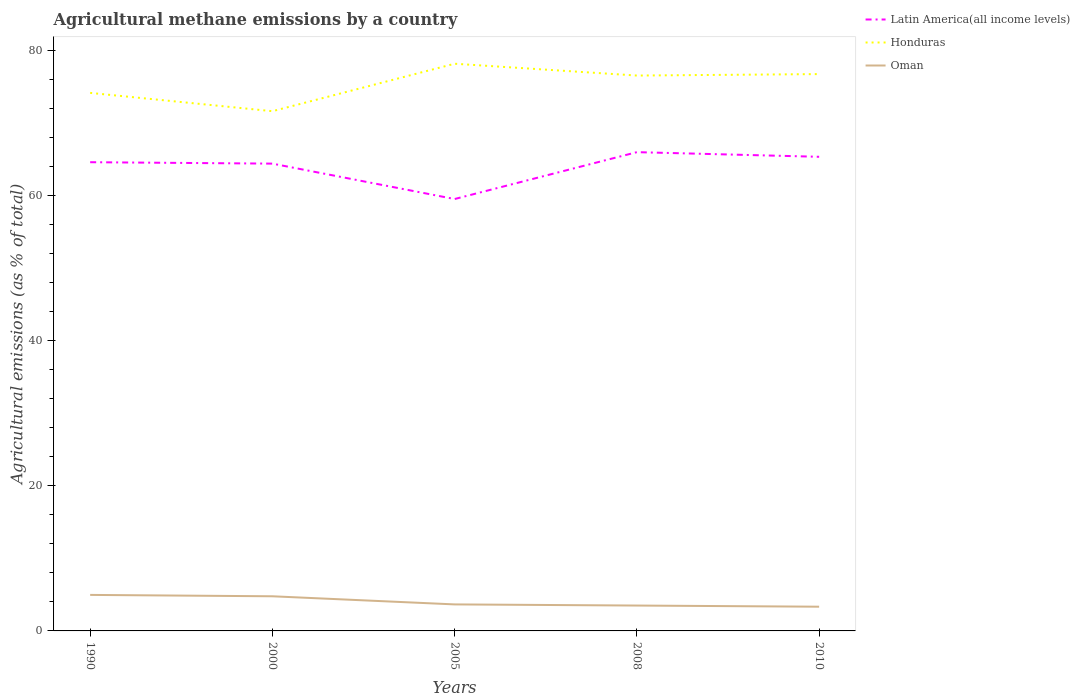How many different coloured lines are there?
Provide a succinct answer. 3. Across all years, what is the maximum amount of agricultural methane emitted in Latin America(all income levels)?
Offer a very short reply. 59.56. What is the total amount of agricultural methane emitted in Latin America(all income levels) in the graph?
Provide a succinct answer. -0.94. What is the difference between the highest and the second highest amount of agricultural methane emitted in Honduras?
Ensure brevity in your answer.  6.55. What is the difference between the highest and the lowest amount of agricultural methane emitted in Honduras?
Make the answer very short. 3. How many lines are there?
Keep it short and to the point. 3. Where does the legend appear in the graph?
Ensure brevity in your answer.  Top right. How are the legend labels stacked?
Offer a very short reply. Vertical. What is the title of the graph?
Ensure brevity in your answer.  Agricultural methane emissions by a country. Does "Monaco" appear as one of the legend labels in the graph?
Give a very brief answer. No. What is the label or title of the X-axis?
Keep it short and to the point. Years. What is the label or title of the Y-axis?
Your answer should be compact. Agricultural emissions (as % of total). What is the Agricultural emissions (as % of total) in Latin America(all income levels) in 1990?
Your response must be concise. 64.63. What is the Agricultural emissions (as % of total) of Honduras in 1990?
Ensure brevity in your answer.  74.19. What is the Agricultural emissions (as % of total) in Oman in 1990?
Give a very brief answer. 4.97. What is the Agricultural emissions (as % of total) in Latin America(all income levels) in 2000?
Make the answer very short. 64.44. What is the Agricultural emissions (as % of total) of Honduras in 2000?
Provide a succinct answer. 71.67. What is the Agricultural emissions (as % of total) of Oman in 2000?
Ensure brevity in your answer.  4.78. What is the Agricultural emissions (as % of total) of Latin America(all income levels) in 2005?
Your answer should be very brief. 59.56. What is the Agricultural emissions (as % of total) of Honduras in 2005?
Give a very brief answer. 78.21. What is the Agricultural emissions (as % of total) in Oman in 2005?
Your answer should be very brief. 3.66. What is the Agricultural emissions (as % of total) in Latin America(all income levels) in 2008?
Provide a short and direct response. 66.02. What is the Agricultural emissions (as % of total) of Honduras in 2008?
Provide a succinct answer. 76.58. What is the Agricultural emissions (as % of total) of Oman in 2008?
Give a very brief answer. 3.5. What is the Agricultural emissions (as % of total) in Latin America(all income levels) in 2010?
Your answer should be compact. 65.38. What is the Agricultural emissions (as % of total) of Honduras in 2010?
Your answer should be compact. 76.78. What is the Agricultural emissions (as % of total) in Oman in 2010?
Give a very brief answer. 3.34. Across all years, what is the maximum Agricultural emissions (as % of total) in Latin America(all income levels)?
Your answer should be very brief. 66.02. Across all years, what is the maximum Agricultural emissions (as % of total) of Honduras?
Provide a succinct answer. 78.21. Across all years, what is the maximum Agricultural emissions (as % of total) of Oman?
Your answer should be compact. 4.97. Across all years, what is the minimum Agricultural emissions (as % of total) in Latin America(all income levels)?
Your answer should be very brief. 59.56. Across all years, what is the minimum Agricultural emissions (as % of total) of Honduras?
Ensure brevity in your answer.  71.67. Across all years, what is the minimum Agricultural emissions (as % of total) of Oman?
Your answer should be compact. 3.34. What is the total Agricultural emissions (as % of total) in Latin America(all income levels) in the graph?
Offer a terse response. 320.03. What is the total Agricultural emissions (as % of total) in Honduras in the graph?
Make the answer very short. 377.44. What is the total Agricultural emissions (as % of total) of Oman in the graph?
Offer a very short reply. 20.24. What is the difference between the Agricultural emissions (as % of total) of Latin America(all income levels) in 1990 and that in 2000?
Your answer should be very brief. 0.2. What is the difference between the Agricultural emissions (as % of total) of Honduras in 1990 and that in 2000?
Offer a terse response. 2.52. What is the difference between the Agricultural emissions (as % of total) in Oman in 1990 and that in 2000?
Give a very brief answer. 0.19. What is the difference between the Agricultural emissions (as % of total) in Latin America(all income levels) in 1990 and that in 2005?
Keep it short and to the point. 5.08. What is the difference between the Agricultural emissions (as % of total) in Honduras in 1990 and that in 2005?
Keep it short and to the point. -4.02. What is the difference between the Agricultural emissions (as % of total) in Oman in 1990 and that in 2005?
Make the answer very short. 1.31. What is the difference between the Agricultural emissions (as % of total) in Latin America(all income levels) in 1990 and that in 2008?
Offer a very short reply. -1.39. What is the difference between the Agricultural emissions (as % of total) of Honduras in 1990 and that in 2008?
Offer a very short reply. -2.39. What is the difference between the Agricultural emissions (as % of total) in Oman in 1990 and that in 2008?
Provide a short and direct response. 1.47. What is the difference between the Agricultural emissions (as % of total) in Latin America(all income levels) in 1990 and that in 2010?
Keep it short and to the point. -0.75. What is the difference between the Agricultural emissions (as % of total) in Honduras in 1990 and that in 2010?
Provide a short and direct response. -2.59. What is the difference between the Agricultural emissions (as % of total) of Oman in 1990 and that in 2010?
Make the answer very short. 1.63. What is the difference between the Agricultural emissions (as % of total) of Latin America(all income levels) in 2000 and that in 2005?
Your response must be concise. 4.88. What is the difference between the Agricultural emissions (as % of total) of Honduras in 2000 and that in 2005?
Offer a very short reply. -6.55. What is the difference between the Agricultural emissions (as % of total) of Oman in 2000 and that in 2005?
Your answer should be compact. 1.12. What is the difference between the Agricultural emissions (as % of total) in Latin America(all income levels) in 2000 and that in 2008?
Offer a very short reply. -1.58. What is the difference between the Agricultural emissions (as % of total) in Honduras in 2000 and that in 2008?
Provide a succinct answer. -4.92. What is the difference between the Agricultural emissions (as % of total) of Oman in 2000 and that in 2008?
Give a very brief answer. 1.28. What is the difference between the Agricultural emissions (as % of total) in Latin America(all income levels) in 2000 and that in 2010?
Your answer should be very brief. -0.94. What is the difference between the Agricultural emissions (as % of total) of Honduras in 2000 and that in 2010?
Offer a terse response. -5.12. What is the difference between the Agricultural emissions (as % of total) of Oman in 2000 and that in 2010?
Your answer should be compact. 1.44. What is the difference between the Agricultural emissions (as % of total) in Latin America(all income levels) in 2005 and that in 2008?
Keep it short and to the point. -6.46. What is the difference between the Agricultural emissions (as % of total) of Honduras in 2005 and that in 2008?
Provide a succinct answer. 1.63. What is the difference between the Agricultural emissions (as % of total) in Oman in 2005 and that in 2008?
Provide a short and direct response. 0.16. What is the difference between the Agricultural emissions (as % of total) of Latin America(all income levels) in 2005 and that in 2010?
Your response must be concise. -5.82. What is the difference between the Agricultural emissions (as % of total) in Honduras in 2005 and that in 2010?
Provide a succinct answer. 1.43. What is the difference between the Agricultural emissions (as % of total) of Oman in 2005 and that in 2010?
Ensure brevity in your answer.  0.32. What is the difference between the Agricultural emissions (as % of total) of Latin America(all income levels) in 2008 and that in 2010?
Provide a short and direct response. 0.64. What is the difference between the Agricultural emissions (as % of total) in Honduras in 2008 and that in 2010?
Your answer should be compact. -0.2. What is the difference between the Agricultural emissions (as % of total) of Oman in 2008 and that in 2010?
Your answer should be compact. 0.16. What is the difference between the Agricultural emissions (as % of total) of Latin America(all income levels) in 1990 and the Agricultural emissions (as % of total) of Honduras in 2000?
Offer a very short reply. -7.03. What is the difference between the Agricultural emissions (as % of total) in Latin America(all income levels) in 1990 and the Agricultural emissions (as % of total) in Oman in 2000?
Offer a very short reply. 59.86. What is the difference between the Agricultural emissions (as % of total) of Honduras in 1990 and the Agricultural emissions (as % of total) of Oman in 2000?
Provide a succinct answer. 69.42. What is the difference between the Agricultural emissions (as % of total) of Latin America(all income levels) in 1990 and the Agricultural emissions (as % of total) of Honduras in 2005?
Provide a short and direct response. -13.58. What is the difference between the Agricultural emissions (as % of total) in Latin America(all income levels) in 1990 and the Agricultural emissions (as % of total) in Oman in 2005?
Your response must be concise. 60.98. What is the difference between the Agricultural emissions (as % of total) in Honduras in 1990 and the Agricultural emissions (as % of total) in Oman in 2005?
Keep it short and to the point. 70.54. What is the difference between the Agricultural emissions (as % of total) in Latin America(all income levels) in 1990 and the Agricultural emissions (as % of total) in Honduras in 2008?
Keep it short and to the point. -11.95. What is the difference between the Agricultural emissions (as % of total) in Latin America(all income levels) in 1990 and the Agricultural emissions (as % of total) in Oman in 2008?
Keep it short and to the point. 61.14. What is the difference between the Agricultural emissions (as % of total) in Honduras in 1990 and the Agricultural emissions (as % of total) in Oman in 2008?
Provide a succinct answer. 70.69. What is the difference between the Agricultural emissions (as % of total) in Latin America(all income levels) in 1990 and the Agricultural emissions (as % of total) in Honduras in 2010?
Ensure brevity in your answer.  -12.15. What is the difference between the Agricultural emissions (as % of total) of Latin America(all income levels) in 1990 and the Agricultural emissions (as % of total) of Oman in 2010?
Make the answer very short. 61.3. What is the difference between the Agricultural emissions (as % of total) of Honduras in 1990 and the Agricultural emissions (as % of total) of Oman in 2010?
Offer a very short reply. 70.85. What is the difference between the Agricultural emissions (as % of total) in Latin America(all income levels) in 2000 and the Agricultural emissions (as % of total) in Honduras in 2005?
Make the answer very short. -13.78. What is the difference between the Agricultural emissions (as % of total) of Latin America(all income levels) in 2000 and the Agricultural emissions (as % of total) of Oman in 2005?
Provide a succinct answer. 60.78. What is the difference between the Agricultural emissions (as % of total) in Honduras in 2000 and the Agricultural emissions (as % of total) in Oman in 2005?
Keep it short and to the point. 68.01. What is the difference between the Agricultural emissions (as % of total) of Latin America(all income levels) in 2000 and the Agricultural emissions (as % of total) of Honduras in 2008?
Offer a very short reply. -12.15. What is the difference between the Agricultural emissions (as % of total) of Latin America(all income levels) in 2000 and the Agricultural emissions (as % of total) of Oman in 2008?
Your answer should be compact. 60.94. What is the difference between the Agricultural emissions (as % of total) of Honduras in 2000 and the Agricultural emissions (as % of total) of Oman in 2008?
Provide a short and direct response. 68.17. What is the difference between the Agricultural emissions (as % of total) of Latin America(all income levels) in 2000 and the Agricultural emissions (as % of total) of Honduras in 2010?
Your answer should be compact. -12.35. What is the difference between the Agricultural emissions (as % of total) of Latin America(all income levels) in 2000 and the Agricultural emissions (as % of total) of Oman in 2010?
Ensure brevity in your answer.  61.1. What is the difference between the Agricultural emissions (as % of total) of Honduras in 2000 and the Agricultural emissions (as % of total) of Oman in 2010?
Your answer should be very brief. 68.33. What is the difference between the Agricultural emissions (as % of total) in Latin America(all income levels) in 2005 and the Agricultural emissions (as % of total) in Honduras in 2008?
Your answer should be very brief. -17.03. What is the difference between the Agricultural emissions (as % of total) in Latin America(all income levels) in 2005 and the Agricultural emissions (as % of total) in Oman in 2008?
Make the answer very short. 56.06. What is the difference between the Agricultural emissions (as % of total) of Honduras in 2005 and the Agricultural emissions (as % of total) of Oman in 2008?
Provide a short and direct response. 74.71. What is the difference between the Agricultural emissions (as % of total) of Latin America(all income levels) in 2005 and the Agricultural emissions (as % of total) of Honduras in 2010?
Make the answer very short. -17.23. What is the difference between the Agricultural emissions (as % of total) in Latin America(all income levels) in 2005 and the Agricultural emissions (as % of total) in Oman in 2010?
Provide a short and direct response. 56.22. What is the difference between the Agricultural emissions (as % of total) of Honduras in 2005 and the Agricultural emissions (as % of total) of Oman in 2010?
Your answer should be very brief. 74.88. What is the difference between the Agricultural emissions (as % of total) of Latin America(all income levels) in 2008 and the Agricultural emissions (as % of total) of Honduras in 2010?
Ensure brevity in your answer.  -10.76. What is the difference between the Agricultural emissions (as % of total) in Latin America(all income levels) in 2008 and the Agricultural emissions (as % of total) in Oman in 2010?
Your answer should be compact. 62.68. What is the difference between the Agricultural emissions (as % of total) in Honduras in 2008 and the Agricultural emissions (as % of total) in Oman in 2010?
Make the answer very short. 73.24. What is the average Agricultural emissions (as % of total) in Latin America(all income levels) per year?
Provide a succinct answer. 64.01. What is the average Agricultural emissions (as % of total) in Honduras per year?
Provide a short and direct response. 75.49. What is the average Agricultural emissions (as % of total) of Oman per year?
Your response must be concise. 4.05. In the year 1990, what is the difference between the Agricultural emissions (as % of total) of Latin America(all income levels) and Agricultural emissions (as % of total) of Honduras?
Make the answer very short. -9.56. In the year 1990, what is the difference between the Agricultural emissions (as % of total) in Latin America(all income levels) and Agricultural emissions (as % of total) in Oman?
Your answer should be compact. 59.67. In the year 1990, what is the difference between the Agricultural emissions (as % of total) in Honduras and Agricultural emissions (as % of total) in Oman?
Offer a terse response. 69.23. In the year 2000, what is the difference between the Agricultural emissions (as % of total) of Latin America(all income levels) and Agricultural emissions (as % of total) of Honduras?
Provide a short and direct response. -7.23. In the year 2000, what is the difference between the Agricultural emissions (as % of total) in Latin America(all income levels) and Agricultural emissions (as % of total) in Oman?
Your answer should be compact. 59.66. In the year 2000, what is the difference between the Agricultural emissions (as % of total) of Honduras and Agricultural emissions (as % of total) of Oman?
Ensure brevity in your answer.  66.89. In the year 2005, what is the difference between the Agricultural emissions (as % of total) in Latin America(all income levels) and Agricultural emissions (as % of total) in Honduras?
Offer a terse response. -18.66. In the year 2005, what is the difference between the Agricultural emissions (as % of total) in Latin America(all income levels) and Agricultural emissions (as % of total) in Oman?
Ensure brevity in your answer.  55.9. In the year 2005, what is the difference between the Agricultural emissions (as % of total) of Honduras and Agricultural emissions (as % of total) of Oman?
Provide a succinct answer. 74.56. In the year 2008, what is the difference between the Agricultural emissions (as % of total) in Latin America(all income levels) and Agricultural emissions (as % of total) in Honduras?
Offer a very short reply. -10.56. In the year 2008, what is the difference between the Agricultural emissions (as % of total) of Latin America(all income levels) and Agricultural emissions (as % of total) of Oman?
Your response must be concise. 62.52. In the year 2008, what is the difference between the Agricultural emissions (as % of total) in Honduras and Agricultural emissions (as % of total) in Oman?
Offer a terse response. 73.08. In the year 2010, what is the difference between the Agricultural emissions (as % of total) of Latin America(all income levels) and Agricultural emissions (as % of total) of Honduras?
Ensure brevity in your answer.  -11.4. In the year 2010, what is the difference between the Agricultural emissions (as % of total) of Latin America(all income levels) and Agricultural emissions (as % of total) of Oman?
Offer a terse response. 62.04. In the year 2010, what is the difference between the Agricultural emissions (as % of total) of Honduras and Agricultural emissions (as % of total) of Oman?
Offer a very short reply. 73.45. What is the ratio of the Agricultural emissions (as % of total) of Latin America(all income levels) in 1990 to that in 2000?
Keep it short and to the point. 1. What is the ratio of the Agricultural emissions (as % of total) of Honduras in 1990 to that in 2000?
Keep it short and to the point. 1.04. What is the ratio of the Agricultural emissions (as % of total) in Oman in 1990 to that in 2000?
Make the answer very short. 1.04. What is the ratio of the Agricultural emissions (as % of total) of Latin America(all income levels) in 1990 to that in 2005?
Give a very brief answer. 1.09. What is the ratio of the Agricultural emissions (as % of total) in Honduras in 1990 to that in 2005?
Your response must be concise. 0.95. What is the ratio of the Agricultural emissions (as % of total) in Oman in 1990 to that in 2005?
Give a very brief answer. 1.36. What is the ratio of the Agricultural emissions (as % of total) in Honduras in 1990 to that in 2008?
Your answer should be very brief. 0.97. What is the ratio of the Agricultural emissions (as % of total) of Oman in 1990 to that in 2008?
Provide a short and direct response. 1.42. What is the ratio of the Agricultural emissions (as % of total) in Honduras in 1990 to that in 2010?
Ensure brevity in your answer.  0.97. What is the ratio of the Agricultural emissions (as % of total) of Oman in 1990 to that in 2010?
Your answer should be very brief. 1.49. What is the ratio of the Agricultural emissions (as % of total) in Latin America(all income levels) in 2000 to that in 2005?
Provide a succinct answer. 1.08. What is the ratio of the Agricultural emissions (as % of total) of Honduras in 2000 to that in 2005?
Give a very brief answer. 0.92. What is the ratio of the Agricultural emissions (as % of total) in Oman in 2000 to that in 2005?
Provide a succinct answer. 1.31. What is the ratio of the Agricultural emissions (as % of total) of Latin America(all income levels) in 2000 to that in 2008?
Offer a very short reply. 0.98. What is the ratio of the Agricultural emissions (as % of total) in Honduras in 2000 to that in 2008?
Provide a short and direct response. 0.94. What is the ratio of the Agricultural emissions (as % of total) of Oman in 2000 to that in 2008?
Offer a very short reply. 1.36. What is the ratio of the Agricultural emissions (as % of total) of Latin America(all income levels) in 2000 to that in 2010?
Offer a terse response. 0.99. What is the ratio of the Agricultural emissions (as % of total) in Honduras in 2000 to that in 2010?
Provide a short and direct response. 0.93. What is the ratio of the Agricultural emissions (as % of total) of Oman in 2000 to that in 2010?
Offer a very short reply. 1.43. What is the ratio of the Agricultural emissions (as % of total) of Latin America(all income levels) in 2005 to that in 2008?
Offer a very short reply. 0.9. What is the ratio of the Agricultural emissions (as % of total) of Honduras in 2005 to that in 2008?
Provide a succinct answer. 1.02. What is the ratio of the Agricultural emissions (as % of total) of Oman in 2005 to that in 2008?
Provide a short and direct response. 1.04. What is the ratio of the Agricultural emissions (as % of total) in Latin America(all income levels) in 2005 to that in 2010?
Keep it short and to the point. 0.91. What is the ratio of the Agricultural emissions (as % of total) of Honduras in 2005 to that in 2010?
Provide a succinct answer. 1.02. What is the ratio of the Agricultural emissions (as % of total) in Oman in 2005 to that in 2010?
Give a very brief answer. 1.09. What is the ratio of the Agricultural emissions (as % of total) of Latin America(all income levels) in 2008 to that in 2010?
Offer a terse response. 1.01. What is the ratio of the Agricultural emissions (as % of total) of Oman in 2008 to that in 2010?
Provide a succinct answer. 1.05. What is the difference between the highest and the second highest Agricultural emissions (as % of total) in Latin America(all income levels)?
Your response must be concise. 0.64. What is the difference between the highest and the second highest Agricultural emissions (as % of total) of Honduras?
Offer a terse response. 1.43. What is the difference between the highest and the second highest Agricultural emissions (as % of total) in Oman?
Ensure brevity in your answer.  0.19. What is the difference between the highest and the lowest Agricultural emissions (as % of total) of Latin America(all income levels)?
Your response must be concise. 6.46. What is the difference between the highest and the lowest Agricultural emissions (as % of total) in Honduras?
Ensure brevity in your answer.  6.55. What is the difference between the highest and the lowest Agricultural emissions (as % of total) in Oman?
Your answer should be compact. 1.63. 